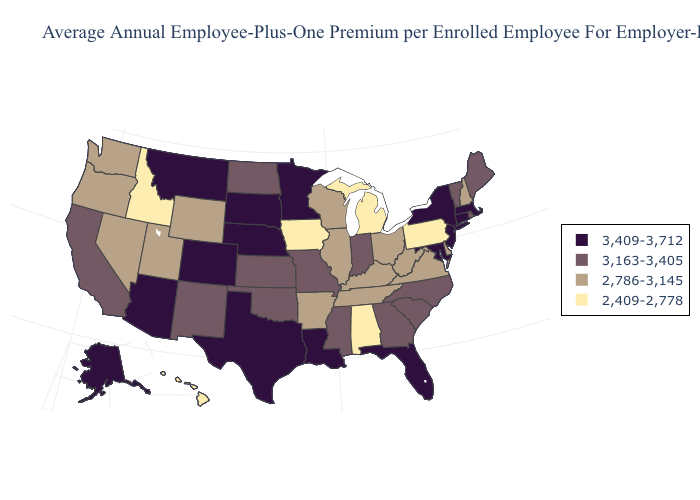Which states have the highest value in the USA?
Concise answer only. Alaska, Arizona, Colorado, Connecticut, Florida, Louisiana, Maryland, Massachusetts, Minnesota, Montana, Nebraska, New Jersey, New York, South Dakota, Texas. What is the value of Wisconsin?
Quick response, please. 2,786-3,145. What is the highest value in the Northeast ?
Quick response, please. 3,409-3,712. Does Georgia have the lowest value in the South?
Keep it brief. No. What is the value of Hawaii?
Keep it brief. 2,409-2,778. What is the value of New Hampshire?
Concise answer only. 2,786-3,145. What is the highest value in the USA?
Write a very short answer. 3,409-3,712. Name the states that have a value in the range 3,409-3,712?
Answer briefly. Alaska, Arizona, Colorado, Connecticut, Florida, Louisiana, Maryland, Massachusetts, Minnesota, Montana, Nebraska, New Jersey, New York, South Dakota, Texas. What is the value of Oregon?
Quick response, please. 2,786-3,145. Does Alabama have the lowest value in the USA?
Keep it brief. Yes. Name the states that have a value in the range 2,409-2,778?
Write a very short answer. Alabama, Hawaii, Idaho, Iowa, Michigan, Pennsylvania. Does the map have missing data?
Be succinct. No. What is the highest value in the USA?
Answer briefly. 3,409-3,712. Among the states that border Mississippi , does Louisiana have the highest value?
Short answer required. Yes. Name the states that have a value in the range 3,163-3,405?
Write a very short answer. California, Georgia, Indiana, Kansas, Maine, Mississippi, Missouri, New Mexico, North Carolina, North Dakota, Oklahoma, Rhode Island, South Carolina, Vermont. 